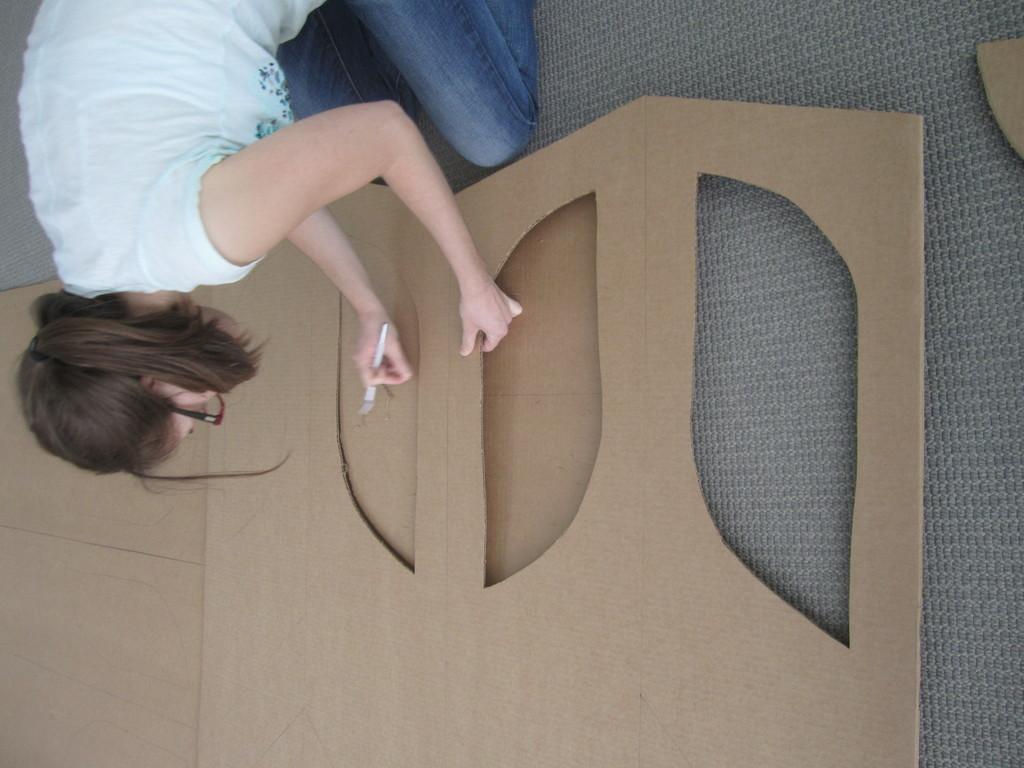Can you describe this image briefly? Here we can see a woman holding an object and a cardboard with her hands. 